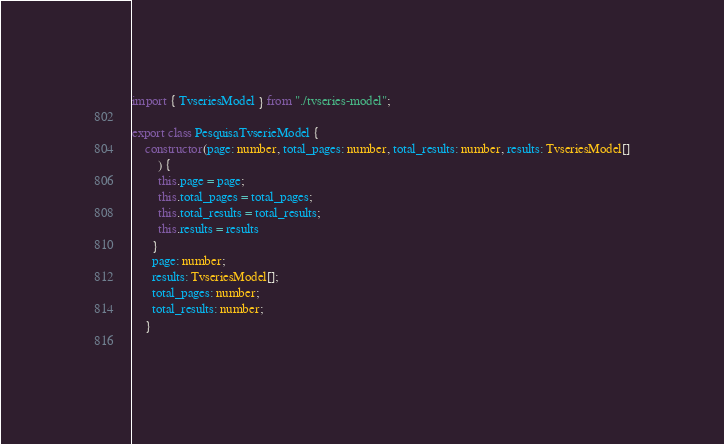Convert code to text. <code><loc_0><loc_0><loc_500><loc_500><_TypeScript_>import { TvseriesModel } from "./tvseries-model";

export class PesquisaTvserieModel {
    constructor(page: number, total_pages: number, total_results: number, results: TvseriesModel[]
        ) {
        this.page = page;
        this.total_pages = total_pages;
        this.total_results = total_results;
        this.results = results
      }
      page: number;
      results: TvseriesModel[];
      total_pages: number;
      total_results: number;
    }
    </code> 